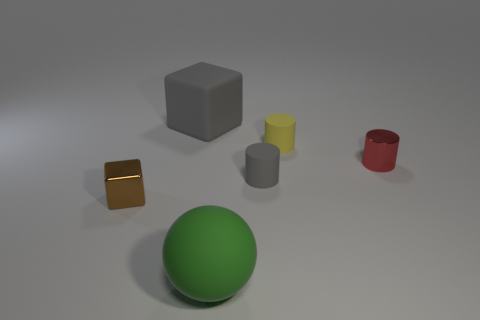There is a tiny object that is to the left of the big green rubber ball; what material is it?
Keep it short and to the point. Metal. The big thing that is in front of the tiny yellow matte object is what color?
Offer a terse response. Green. Are there fewer small matte cylinders in front of the green sphere than small gray objects?
Ensure brevity in your answer.  Yes. Do the tiny gray cylinder and the tiny red cylinder have the same material?
Keep it short and to the point. No. How many things are tiny things that are behind the brown shiny object or large matte things in front of the large gray thing?
Keep it short and to the point. 4. Are there any red metal objects that have the same size as the green matte object?
Keep it short and to the point. No. What color is the tiny metal thing that is the same shape as the tiny yellow rubber thing?
Provide a succinct answer. Red. Are there any small metal cubes that are behind the matte object in front of the brown shiny thing?
Ensure brevity in your answer.  Yes. There is a gray rubber thing on the left side of the green thing; is it the same shape as the yellow rubber object?
Offer a very short reply. No. What is the shape of the brown metallic thing?
Your response must be concise. Cube. 